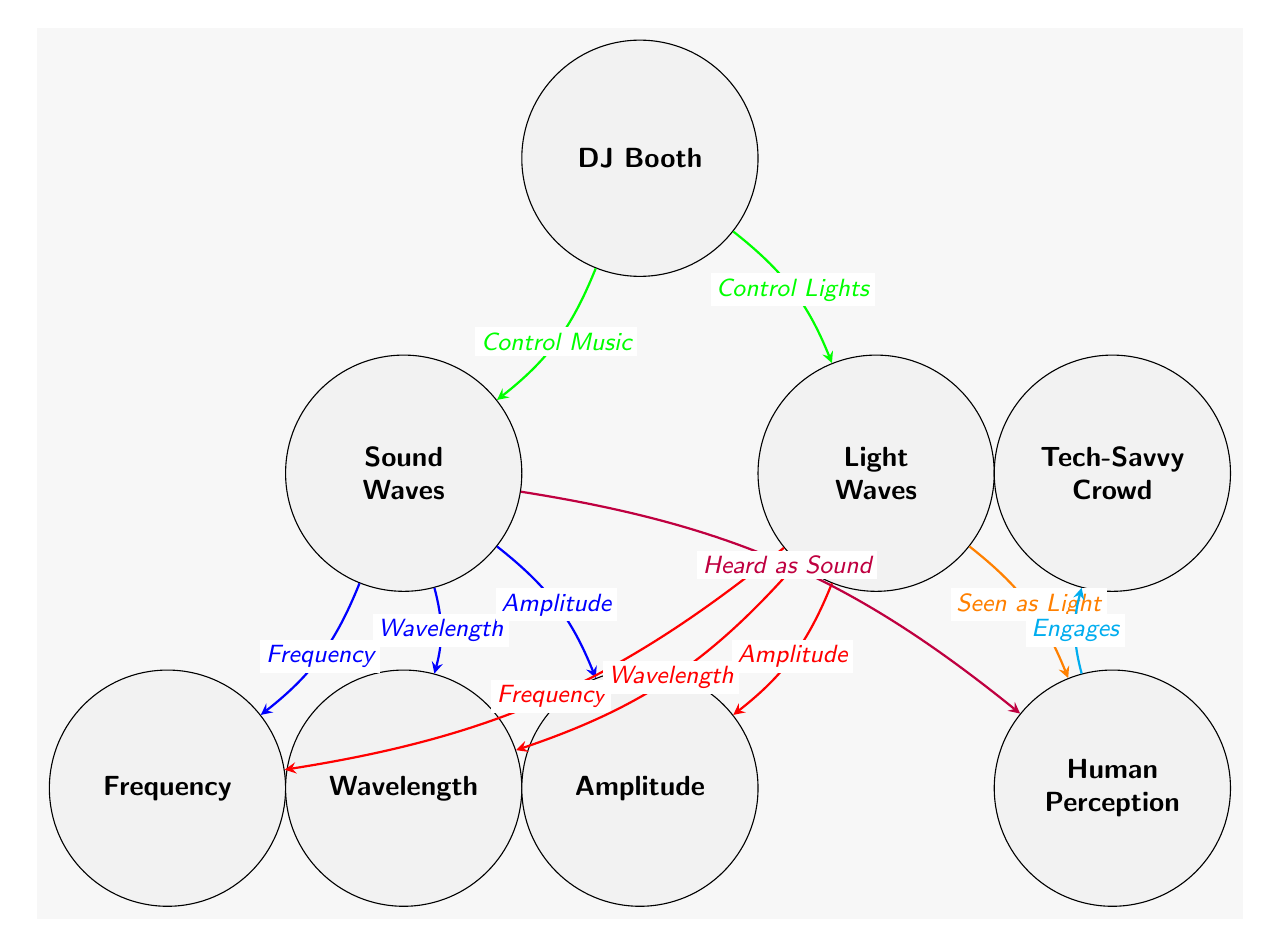What are the two main types of waves represented in this diagram? The diagram shows two main types of waves: Sound Waves and Light Waves, which are clearly labeled at the top of the diagram.
Answer: Sound Waves, Light Waves How many node types are there in the diagram? The diagram includes six distinct nodes: Sound Waves, Light Waves, Frequency, Wavelength, Amplitude, and Human Perception. By counting these unique nodes, we find there are six types.
Answer: 6 What is the relationship labeled between Sound Waves and Frequency? The diagram has an edge connecting Sound Waves to Frequency with a label indicating that they are related through Frequency, indicated by a blue arrow pointing from Sound Waves to Frequency.
Answer: Frequency Which node is directly related to both the DJ Booth and Sound Waves? The DJ Booth connects to Sound Waves through the edge labeled "Control Music." This direct connection shows the DJ's influence over Sound Waves.
Answer: Sound Waves What color represents the relationship stemming from Light Waves to human perception? The diagram displays a relationship from Light Waves to Human Perception as "Seen as Light," indicated by an orange arrow. The color orange clearly represents this connection.
Answer: Orange Explain how the DJ influences both sound and light according to the diagram. The DJ Booth has two outgoing arrows, one pointing to Sound Waves labeled "Control Music" and another pointing to Light Waves labeled "Control Lights." This indicates the DJ's ability to manipulate both aspects in the music shows.
Answer: DJ Booth Which node does the Tech-Savvy Crowd engage with according to the diagram? There is a cyan edge that connects Human Perception to Tech-Savvy Crowd, labeled "Engages." This signifies that the crowd engages based on their perception of the music and lights.
Answer: Tech-Savvy Crowd Identify the node connected to both Frequency and Amplitude by ARROWS. Both Frequency and Amplitude are connected to Sound Waves and Light Waves, but primarily they stem from each of the wave types, shown in the blue and red relationships, respectively.
Answer: Frequency, Amplitude What two aspects of sound waves and light waves are interconnected based on the labels in the diagram? The labels indicate that both types of waves have similar characteristics, as reflected in Frequency, Wavelength, and Amplitude. This suggests a comparative nature.
Answer: Frequency, Wavelength, Amplitude 